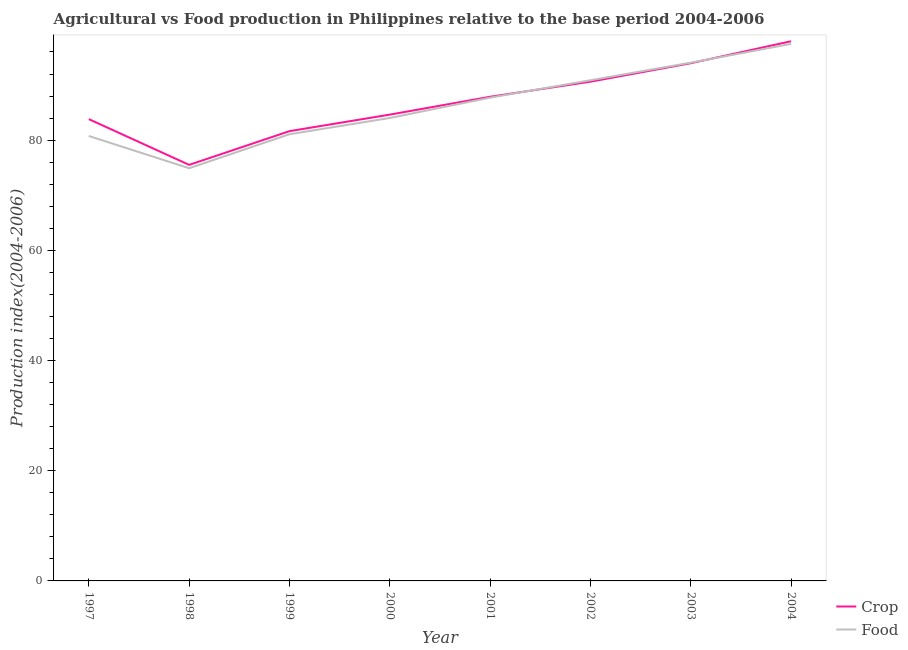How many different coloured lines are there?
Ensure brevity in your answer.  2. Does the line corresponding to food production index intersect with the line corresponding to crop production index?
Offer a terse response. Yes. What is the crop production index in 2003?
Provide a succinct answer. 93.96. Across all years, what is the maximum food production index?
Offer a very short reply. 97.47. Across all years, what is the minimum crop production index?
Offer a terse response. 75.51. In which year was the crop production index maximum?
Provide a short and direct response. 2004. In which year was the food production index minimum?
Give a very brief answer. 1998. What is the total crop production index in the graph?
Provide a short and direct response. 695.97. What is the difference between the crop production index in 1998 and that in 1999?
Your answer should be very brief. -6.12. What is the difference between the food production index in 2004 and the crop production index in 1999?
Offer a very short reply. 15.84. What is the average food production index per year?
Your answer should be very brief. 86.36. In the year 2000, what is the difference between the food production index and crop production index?
Offer a very short reply. -0.61. In how many years, is the crop production index greater than 44?
Give a very brief answer. 8. What is the ratio of the crop production index in 2001 to that in 2002?
Your answer should be very brief. 0.97. Is the difference between the crop production index in 2000 and 2003 greater than the difference between the food production index in 2000 and 2003?
Offer a terse response. Yes. What is the difference between the highest and the second highest food production index?
Your answer should be very brief. 3.41. What is the difference between the highest and the lowest crop production index?
Keep it short and to the point. 22.44. Is the sum of the food production index in 1998 and 2001 greater than the maximum crop production index across all years?
Your answer should be very brief. Yes. Does the crop production index monotonically increase over the years?
Your answer should be compact. No. Is the crop production index strictly greater than the food production index over the years?
Your answer should be compact. No. Is the food production index strictly less than the crop production index over the years?
Your answer should be compact. No. How many lines are there?
Make the answer very short. 2. What is the difference between two consecutive major ticks on the Y-axis?
Your response must be concise. 20. Are the values on the major ticks of Y-axis written in scientific E-notation?
Ensure brevity in your answer.  No. How many legend labels are there?
Keep it short and to the point. 2. How are the legend labels stacked?
Keep it short and to the point. Vertical. What is the title of the graph?
Your response must be concise. Agricultural vs Food production in Philippines relative to the base period 2004-2006. Does "Services" appear as one of the legend labels in the graph?
Give a very brief answer. No. What is the label or title of the Y-axis?
Give a very brief answer. Production index(2004-2006). What is the Production index(2004-2006) of Crop in 1997?
Make the answer very short. 83.81. What is the Production index(2004-2006) of Food in 1997?
Your response must be concise. 80.75. What is the Production index(2004-2006) in Crop in 1998?
Provide a short and direct response. 75.51. What is the Production index(2004-2006) of Food in 1998?
Make the answer very short. 74.9. What is the Production index(2004-2006) of Crop in 1999?
Make the answer very short. 81.63. What is the Production index(2004-2006) of Food in 1999?
Offer a very short reply. 81.07. What is the Production index(2004-2006) of Crop in 2000?
Give a very brief answer. 84.63. What is the Production index(2004-2006) in Food in 2000?
Offer a very short reply. 84.02. What is the Production index(2004-2006) in Crop in 2001?
Keep it short and to the point. 87.87. What is the Production index(2004-2006) in Food in 2001?
Give a very brief answer. 87.71. What is the Production index(2004-2006) of Crop in 2002?
Your answer should be compact. 90.61. What is the Production index(2004-2006) in Food in 2002?
Provide a succinct answer. 90.87. What is the Production index(2004-2006) in Crop in 2003?
Provide a short and direct response. 93.96. What is the Production index(2004-2006) of Food in 2003?
Keep it short and to the point. 94.06. What is the Production index(2004-2006) in Crop in 2004?
Keep it short and to the point. 97.95. What is the Production index(2004-2006) of Food in 2004?
Give a very brief answer. 97.47. Across all years, what is the maximum Production index(2004-2006) of Crop?
Your response must be concise. 97.95. Across all years, what is the maximum Production index(2004-2006) of Food?
Your response must be concise. 97.47. Across all years, what is the minimum Production index(2004-2006) of Crop?
Your answer should be compact. 75.51. Across all years, what is the minimum Production index(2004-2006) in Food?
Your answer should be compact. 74.9. What is the total Production index(2004-2006) of Crop in the graph?
Keep it short and to the point. 695.97. What is the total Production index(2004-2006) in Food in the graph?
Ensure brevity in your answer.  690.85. What is the difference between the Production index(2004-2006) of Crop in 1997 and that in 1998?
Your answer should be very brief. 8.3. What is the difference between the Production index(2004-2006) in Food in 1997 and that in 1998?
Give a very brief answer. 5.85. What is the difference between the Production index(2004-2006) in Crop in 1997 and that in 1999?
Offer a very short reply. 2.18. What is the difference between the Production index(2004-2006) of Food in 1997 and that in 1999?
Your answer should be compact. -0.32. What is the difference between the Production index(2004-2006) in Crop in 1997 and that in 2000?
Your answer should be very brief. -0.82. What is the difference between the Production index(2004-2006) of Food in 1997 and that in 2000?
Your answer should be very brief. -3.27. What is the difference between the Production index(2004-2006) of Crop in 1997 and that in 2001?
Ensure brevity in your answer.  -4.06. What is the difference between the Production index(2004-2006) in Food in 1997 and that in 2001?
Offer a terse response. -6.96. What is the difference between the Production index(2004-2006) in Food in 1997 and that in 2002?
Offer a very short reply. -10.12. What is the difference between the Production index(2004-2006) of Crop in 1997 and that in 2003?
Keep it short and to the point. -10.15. What is the difference between the Production index(2004-2006) of Food in 1997 and that in 2003?
Keep it short and to the point. -13.31. What is the difference between the Production index(2004-2006) of Crop in 1997 and that in 2004?
Your answer should be compact. -14.14. What is the difference between the Production index(2004-2006) in Food in 1997 and that in 2004?
Keep it short and to the point. -16.72. What is the difference between the Production index(2004-2006) in Crop in 1998 and that in 1999?
Your response must be concise. -6.12. What is the difference between the Production index(2004-2006) of Food in 1998 and that in 1999?
Make the answer very short. -6.17. What is the difference between the Production index(2004-2006) of Crop in 1998 and that in 2000?
Give a very brief answer. -9.12. What is the difference between the Production index(2004-2006) of Food in 1998 and that in 2000?
Make the answer very short. -9.12. What is the difference between the Production index(2004-2006) of Crop in 1998 and that in 2001?
Your response must be concise. -12.36. What is the difference between the Production index(2004-2006) of Food in 1998 and that in 2001?
Your answer should be very brief. -12.81. What is the difference between the Production index(2004-2006) in Crop in 1998 and that in 2002?
Ensure brevity in your answer.  -15.1. What is the difference between the Production index(2004-2006) in Food in 1998 and that in 2002?
Your answer should be compact. -15.97. What is the difference between the Production index(2004-2006) of Crop in 1998 and that in 2003?
Make the answer very short. -18.45. What is the difference between the Production index(2004-2006) of Food in 1998 and that in 2003?
Offer a very short reply. -19.16. What is the difference between the Production index(2004-2006) of Crop in 1998 and that in 2004?
Your answer should be compact. -22.44. What is the difference between the Production index(2004-2006) in Food in 1998 and that in 2004?
Keep it short and to the point. -22.57. What is the difference between the Production index(2004-2006) in Crop in 1999 and that in 2000?
Give a very brief answer. -3. What is the difference between the Production index(2004-2006) of Food in 1999 and that in 2000?
Give a very brief answer. -2.95. What is the difference between the Production index(2004-2006) of Crop in 1999 and that in 2001?
Provide a short and direct response. -6.24. What is the difference between the Production index(2004-2006) of Food in 1999 and that in 2001?
Your answer should be very brief. -6.64. What is the difference between the Production index(2004-2006) of Crop in 1999 and that in 2002?
Your answer should be compact. -8.98. What is the difference between the Production index(2004-2006) in Food in 1999 and that in 2002?
Your answer should be very brief. -9.8. What is the difference between the Production index(2004-2006) of Crop in 1999 and that in 2003?
Offer a terse response. -12.33. What is the difference between the Production index(2004-2006) in Food in 1999 and that in 2003?
Your response must be concise. -12.99. What is the difference between the Production index(2004-2006) in Crop in 1999 and that in 2004?
Make the answer very short. -16.32. What is the difference between the Production index(2004-2006) of Food in 1999 and that in 2004?
Provide a short and direct response. -16.4. What is the difference between the Production index(2004-2006) in Crop in 2000 and that in 2001?
Offer a terse response. -3.24. What is the difference between the Production index(2004-2006) in Food in 2000 and that in 2001?
Your answer should be very brief. -3.69. What is the difference between the Production index(2004-2006) in Crop in 2000 and that in 2002?
Offer a very short reply. -5.98. What is the difference between the Production index(2004-2006) in Food in 2000 and that in 2002?
Your answer should be very brief. -6.85. What is the difference between the Production index(2004-2006) of Crop in 2000 and that in 2003?
Your answer should be compact. -9.33. What is the difference between the Production index(2004-2006) in Food in 2000 and that in 2003?
Ensure brevity in your answer.  -10.04. What is the difference between the Production index(2004-2006) of Crop in 2000 and that in 2004?
Provide a succinct answer. -13.32. What is the difference between the Production index(2004-2006) of Food in 2000 and that in 2004?
Offer a terse response. -13.45. What is the difference between the Production index(2004-2006) in Crop in 2001 and that in 2002?
Your answer should be very brief. -2.74. What is the difference between the Production index(2004-2006) of Food in 2001 and that in 2002?
Your answer should be compact. -3.16. What is the difference between the Production index(2004-2006) of Crop in 2001 and that in 2003?
Offer a terse response. -6.09. What is the difference between the Production index(2004-2006) of Food in 2001 and that in 2003?
Provide a succinct answer. -6.35. What is the difference between the Production index(2004-2006) in Crop in 2001 and that in 2004?
Provide a short and direct response. -10.08. What is the difference between the Production index(2004-2006) of Food in 2001 and that in 2004?
Provide a short and direct response. -9.76. What is the difference between the Production index(2004-2006) of Crop in 2002 and that in 2003?
Offer a terse response. -3.35. What is the difference between the Production index(2004-2006) of Food in 2002 and that in 2003?
Offer a very short reply. -3.19. What is the difference between the Production index(2004-2006) in Crop in 2002 and that in 2004?
Offer a terse response. -7.34. What is the difference between the Production index(2004-2006) in Food in 2002 and that in 2004?
Your answer should be very brief. -6.6. What is the difference between the Production index(2004-2006) of Crop in 2003 and that in 2004?
Your answer should be very brief. -3.99. What is the difference between the Production index(2004-2006) in Food in 2003 and that in 2004?
Keep it short and to the point. -3.41. What is the difference between the Production index(2004-2006) in Crop in 1997 and the Production index(2004-2006) in Food in 1998?
Make the answer very short. 8.91. What is the difference between the Production index(2004-2006) of Crop in 1997 and the Production index(2004-2006) of Food in 1999?
Your answer should be compact. 2.74. What is the difference between the Production index(2004-2006) of Crop in 1997 and the Production index(2004-2006) of Food in 2000?
Provide a succinct answer. -0.21. What is the difference between the Production index(2004-2006) in Crop in 1997 and the Production index(2004-2006) in Food in 2002?
Give a very brief answer. -7.06. What is the difference between the Production index(2004-2006) of Crop in 1997 and the Production index(2004-2006) of Food in 2003?
Offer a terse response. -10.25. What is the difference between the Production index(2004-2006) of Crop in 1997 and the Production index(2004-2006) of Food in 2004?
Your response must be concise. -13.66. What is the difference between the Production index(2004-2006) of Crop in 1998 and the Production index(2004-2006) of Food in 1999?
Keep it short and to the point. -5.56. What is the difference between the Production index(2004-2006) of Crop in 1998 and the Production index(2004-2006) of Food in 2000?
Give a very brief answer. -8.51. What is the difference between the Production index(2004-2006) of Crop in 1998 and the Production index(2004-2006) of Food in 2002?
Offer a very short reply. -15.36. What is the difference between the Production index(2004-2006) of Crop in 1998 and the Production index(2004-2006) of Food in 2003?
Your answer should be compact. -18.55. What is the difference between the Production index(2004-2006) of Crop in 1998 and the Production index(2004-2006) of Food in 2004?
Offer a terse response. -21.96. What is the difference between the Production index(2004-2006) of Crop in 1999 and the Production index(2004-2006) of Food in 2000?
Your response must be concise. -2.39. What is the difference between the Production index(2004-2006) in Crop in 1999 and the Production index(2004-2006) in Food in 2001?
Your answer should be compact. -6.08. What is the difference between the Production index(2004-2006) of Crop in 1999 and the Production index(2004-2006) of Food in 2002?
Provide a short and direct response. -9.24. What is the difference between the Production index(2004-2006) in Crop in 1999 and the Production index(2004-2006) in Food in 2003?
Give a very brief answer. -12.43. What is the difference between the Production index(2004-2006) of Crop in 1999 and the Production index(2004-2006) of Food in 2004?
Your response must be concise. -15.84. What is the difference between the Production index(2004-2006) of Crop in 2000 and the Production index(2004-2006) of Food in 2001?
Offer a very short reply. -3.08. What is the difference between the Production index(2004-2006) of Crop in 2000 and the Production index(2004-2006) of Food in 2002?
Ensure brevity in your answer.  -6.24. What is the difference between the Production index(2004-2006) of Crop in 2000 and the Production index(2004-2006) of Food in 2003?
Your answer should be compact. -9.43. What is the difference between the Production index(2004-2006) of Crop in 2000 and the Production index(2004-2006) of Food in 2004?
Keep it short and to the point. -12.84. What is the difference between the Production index(2004-2006) of Crop in 2001 and the Production index(2004-2006) of Food in 2002?
Offer a very short reply. -3. What is the difference between the Production index(2004-2006) of Crop in 2001 and the Production index(2004-2006) of Food in 2003?
Make the answer very short. -6.19. What is the difference between the Production index(2004-2006) in Crop in 2002 and the Production index(2004-2006) in Food in 2003?
Your answer should be very brief. -3.45. What is the difference between the Production index(2004-2006) in Crop in 2002 and the Production index(2004-2006) in Food in 2004?
Keep it short and to the point. -6.86. What is the difference between the Production index(2004-2006) of Crop in 2003 and the Production index(2004-2006) of Food in 2004?
Your answer should be very brief. -3.51. What is the average Production index(2004-2006) in Crop per year?
Offer a terse response. 87. What is the average Production index(2004-2006) of Food per year?
Keep it short and to the point. 86.36. In the year 1997, what is the difference between the Production index(2004-2006) in Crop and Production index(2004-2006) in Food?
Your answer should be compact. 3.06. In the year 1998, what is the difference between the Production index(2004-2006) of Crop and Production index(2004-2006) of Food?
Your response must be concise. 0.61. In the year 1999, what is the difference between the Production index(2004-2006) of Crop and Production index(2004-2006) of Food?
Offer a very short reply. 0.56. In the year 2000, what is the difference between the Production index(2004-2006) in Crop and Production index(2004-2006) in Food?
Your answer should be compact. 0.61. In the year 2001, what is the difference between the Production index(2004-2006) of Crop and Production index(2004-2006) of Food?
Your answer should be compact. 0.16. In the year 2002, what is the difference between the Production index(2004-2006) of Crop and Production index(2004-2006) of Food?
Make the answer very short. -0.26. In the year 2004, what is the difference between the Production index(2004-2006) in Crop and Production index(2004-2006) in Food?
Offer a terse response. 0.48. What is the ratio of the Production index(2004-2006) of Crop in 1997 to that in 1998?
Your response must be concise. 1.11. What is the ratio of the Production index(2004-2006) in Food in 1997 to that in 1998?
Provide a short and direct response. 1.08. What is the ratio of the Production index(2004-2006) in Crop in 1997 to that in 1999?
Ensure brevity in your answer.  1.03. What is the ratio of the Production index(2004-2006) in Crop in 1997 to that in 2000?
Your response must be concise. 0.99. What is the ratio of the Production index(2004-2006) in Food in 1997 to that in 2000?
Make the answer very short. 0.96. What is the ratio of the Production index(2004-2006) of Crop in 1997 to that in 2001?
Provide a short and direct response. 0.95. What is the ratio of the Production index(2004-2006) of Food in 1997 to that in 2001?
Offer a terse response. 0.92. What is the ratio of the Production index(2004-2006) of Crop in 1997 to that in 2002?
Keep it short and to the point. 0.93. What is the ratio of the Production index(2004-2006) in Food in 1997 to that in 2002?
Your answer should be very brief. 0.89. What is the ratio of the Production index(2004-2006) in Crop in 1997 to that in 2003?
Your answer should be compact. 0.89. What is the ratio of the Production index(2004-2006) in Food in 1997 to that in 2003?
Make the answer very short. 0.86. What is the ratio of the Production index(2004-2006) of Crop in 1997 to that in 2004?
Provide a short and direct response. 0.86. What is the ratio of the Production index(2004-2006) of Food in 1997 to that in 2004?
Provide a succinct answer. 0.83. What is the ratio of the Production index(2004-2006) in Crop in 1998 to that in 1999?
Offer a terse response. 0.93. What is the ratio of the Production index(2004-2006) in Food in 1998 to that in 1999?
Provide a succinct answer. 0.92. What is the ratio of the Production index(2004-2006) of Crop in 1998 to that in 2000?
Provide a succinct answer. 0.89. What is the ratio of the Production index(2004-2006) in Food in 1998 to that in 2000?
Your response must be concise. 0.89. What is the ratio of the Production index(2004-2006) of Crop in 1998 to that in 2001?
Provide a succinct answer. 0.86. What is the ratio of the Production index(2004-2006) of Food in 1998 to that in 2001?
Make the answer very short. 0.85. What is the ratio of the Production index(2004-2006) of Crop in 1998 to that in 2002?
Provide a succinct answer. 0.83. What is the ratio of the Production index(2004-2006) in Food in 1998 to that in 2002?
Provide a succinct answer. 0.82. What is the ratio of the Production index(2004-2006) in Crop in 1998 to that in 2003?
Ensure brevity in your answer.  0.8. What is the ratio of the Production index(2004-2006) of Food in 1998 to that in 2003?
Ensure brevity in your answer.  0.8. What is the ratio of the Production index(2004-2006) in Crop in 1998 to that in 2004?
Your answer should be compact. 0.77. What is the ratio of the Production index(2004-2006) of Food in 1998 to that in 2004?
Give a very brief answer. 0.77. What is the ratio of the Production index(2004-2006) of Crop in 1999 to that in 2000?
Offer a very short reply. 0.96. What is the ratio of the Production index(2004-2006) in Food in 1999 to that in 2000?
Your answer should be very brief. 0.96. What is the ratio of the Production index(2004-2006) of Crop in 1999 to that in 2001?
Your response must be concise. 0.93. What is the ratio of the Production index(2004-2006) in Food in 1999 to that in 2001?
Keep it short and to the point. 0.92. What is the ratio of the Production index(2004-2006) of Crop in 1999 to that in 2002?
Give a very brief answer. 0.9. What is the ratio of the Production index(2004-2006) in Food in 1999 to that in 2002?
Make the answer very short. 0.89. What is the ratio of the Production index(2004-2006) in Crop in 1999 to that in 2003?
Your answer should be very brief. 0.87. What is the ratio of the Production index(2004-2006) in Food in 1999 to that in 2003?
Provide a succinct answer. 0.86. What is the ratio of the Production index(2004-2006) of Crop in 1999 to that in 2004?
Ensure brevity in your answer.  0.83. What is the ratio of the Production index(2004-2006) of Food in 1999 to that in 2004?
Provide a short and direct response. 0.83. What is the ratio of the Production index(2004-2006) of Crop in 2000 to that in 2001?
Offer a very short reply. 0.96. What is the ratio of the Production index(2004-2006) of Food in 2000 to that in 2001?
Offer a terse response. 0.96. What is the ratio of the Production index(2004-2006) in Crop in 2000 to that in 2002?
Provide a short and direct response. 0.93. What is the ratio of the Production index(2004-2006) of Food in 2000 to that in 2002?
Give a very brief answer. 0.92. What is the ratio of the Production index(2004-2006) in Crop in 2000 to that in 2003?
Your response must be concise. 0.9. What is the ratio of the Production index(2004-2006) of Food in 2000 to that in 2003?
Offer a terse response. 0.89. What is the ratio of the Production index(2004-2006) of Crop in 2000 to that in 2004?
Your response must be concise. 0.86. What is the ratio of the Production index(2004-2006) in Food in 2000 to that in 2004?
Your answer should be very brief. 0.86. What is the ratio of the Production index(2004-2006) of Crop in 2001 to that in 2002?
Your response must be concise. 0.97. What is the ratio of the Production index(2004-2006) of Food in 2001 to that in 2002?
Offer a terse response. 0.97. What is the ratio of the Production index(2004-2006) of Crop in 2001 to that in 2003?
Ensure brevity in your answer.  0.94. What is the ratio of the Production index(2004-2006) of Food in 2001 to that in 2003?
Your response must be concise. 0.93. What is the ratio of the Production index(2004-2006) in Crop in 2001 to that in 2004?
Offer a terse response. 0.9. What is the ratio of the Production index(2004-2006) of Food in 2001 to that in 2004?
Your answer should be compact. 0.9. What is the ratio of the Production index(2004-2006) of Crop in 2002 to that in 2003?
Provide a short and direct response. 0.96. What is the ratio of the Production index(2004-2006) in Food in 2002 to that in 2003?
Your response must be concise. 0.97. What is the ratio of the Production index(2004-2006) of Crop in 2002 to that in 2004?
Your response must be concise. 0.93. What is the ratio of the Production index(2004-2006) in Food in 2002 to that in 2004?
Make the answer very short. 0.93. What is the ratio of the Production index(2004-2006) of Crop in 2003 to that in 2004?
Keep it short and to the point. 0.96. What is the difference between the highest and the second highest Production index(2004-2006) of Crop?
Your answer should be compact. 3.99. What is the difference between the highest and the second highest Production index(2004-2006) in Food?
Your response must be concise. 3.41. What is the difference between the highest and the lowest Production index(2004-2006) in Crop?
Your response must be concise. 22.44. What is the difference between the highest and the lowest Production index(2004-2006) of Food?
Your response must be concise. 22.57. 